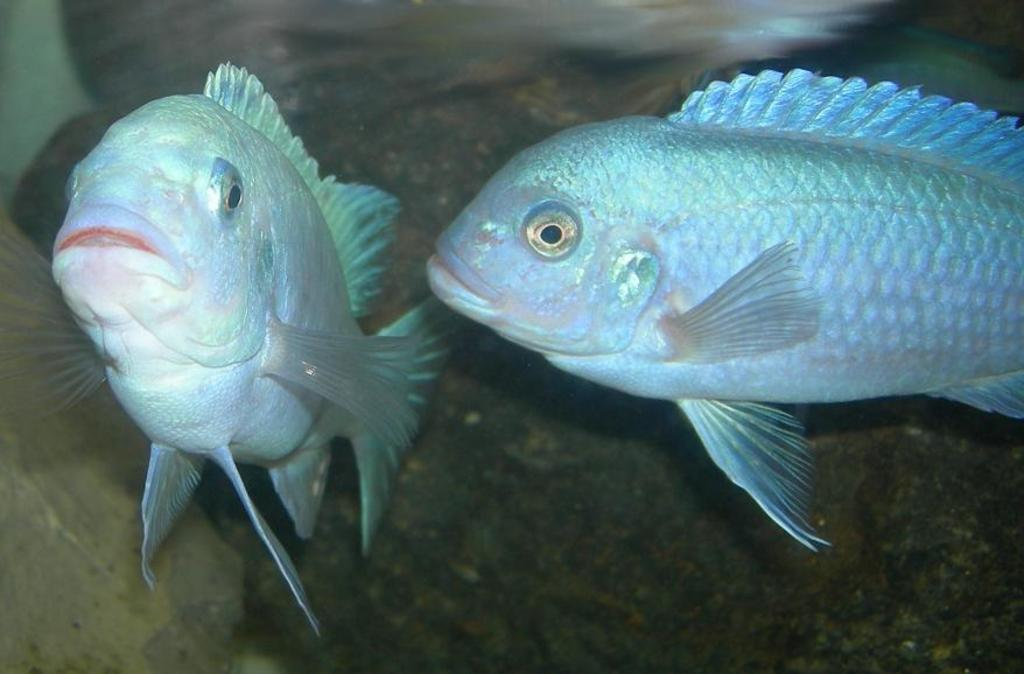What animals are present in the image? There are two fishes in the image. Can you describe the background of the image? The background of the image is blurred. What color is the shirt worn by the nose in the image? There is no nose or shirt present in the image; it features two fishes with a blurred background. 